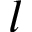<formula> <loc_0><loc_0><loc_500><loc_500>l</formula> 